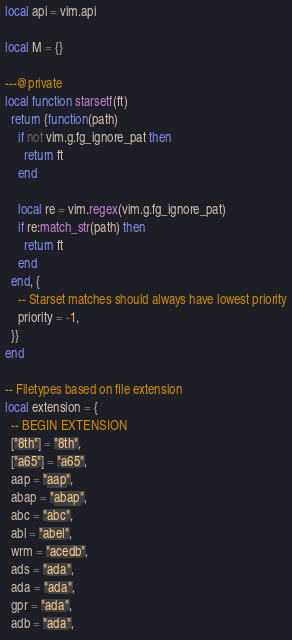<code> <loc_0><loc_0><loc_500><loc_500><_Lua_>local api = vim.api

local M = {}

---@private
local function starsetf(ft)
  return {function(path)
    if not vim.g.fg_ignore_pat then
      return ft
    end

    local re = vim.regex(vim.g.fg_ignore_pat)
    if re:match_str(path) then
      return ft
    end
  end, {
    -- Starset matches should always have lowest priority
    priority = -1,
  }}
end

-- Filetypes based on file extension
local extension = {
  -- BEGIN EXTENSION
  ["8th"] = "8th",
  ["a65"] = "a65",
  aap = "aap",
  abap = "abap",
  abc = "abc",
  abl = "abel",
  wrm = "acedb",
  ads = "ada",
  ada = "ada",
  gpr = "ada",
  adb = "ada",</code> 